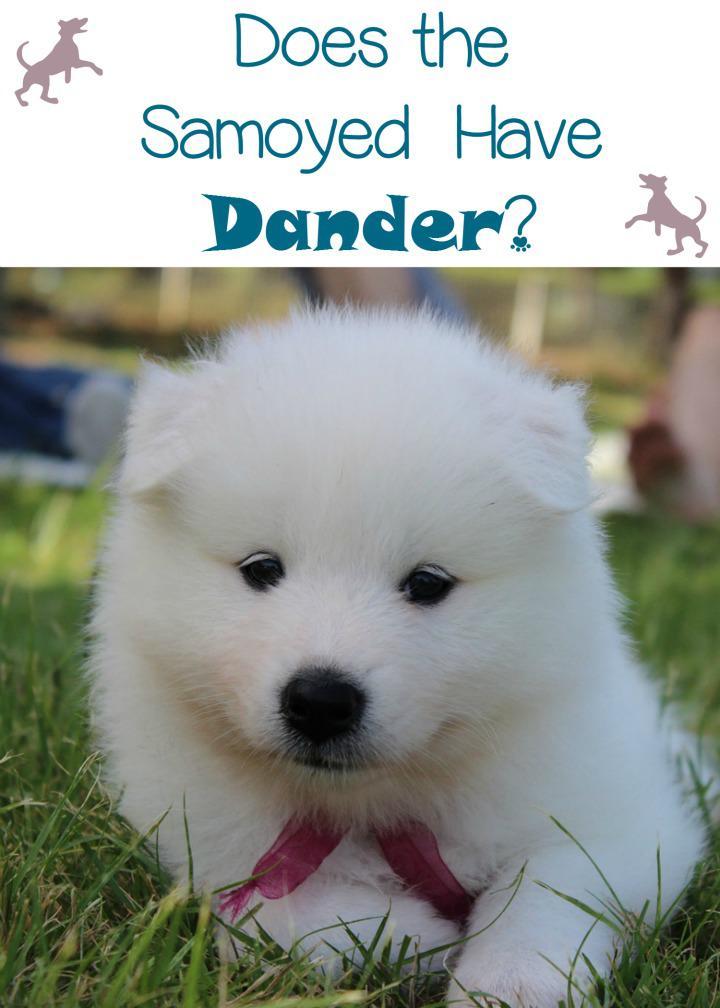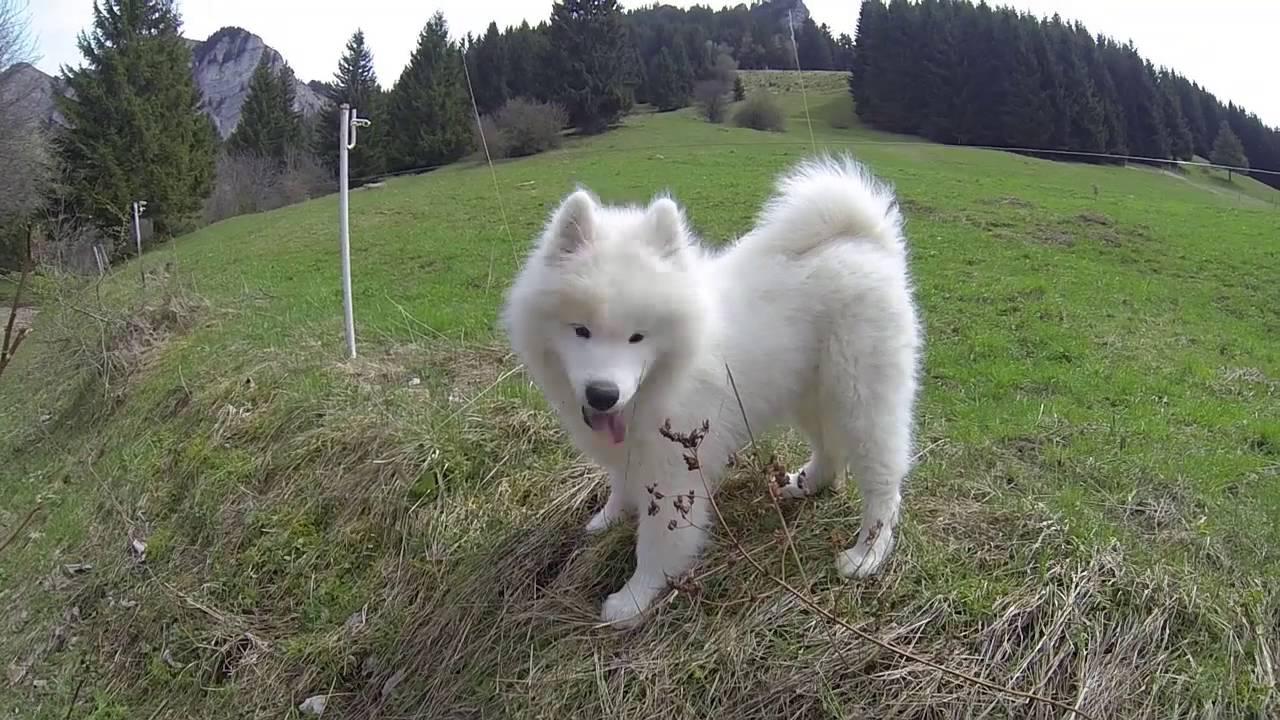The first image is the image on the left, the second image is the image on the right. Given the left and right images, does the statement "There are no more then two white dogs." hold true? Answer yes or no. Yes. The first image is the image on the left, the second image is the image on the right. Given the left and right images, does the statement "An image shows a young white dog next to a reclining large white dog on bright green grass." hold true? Answer yes or no. No. 